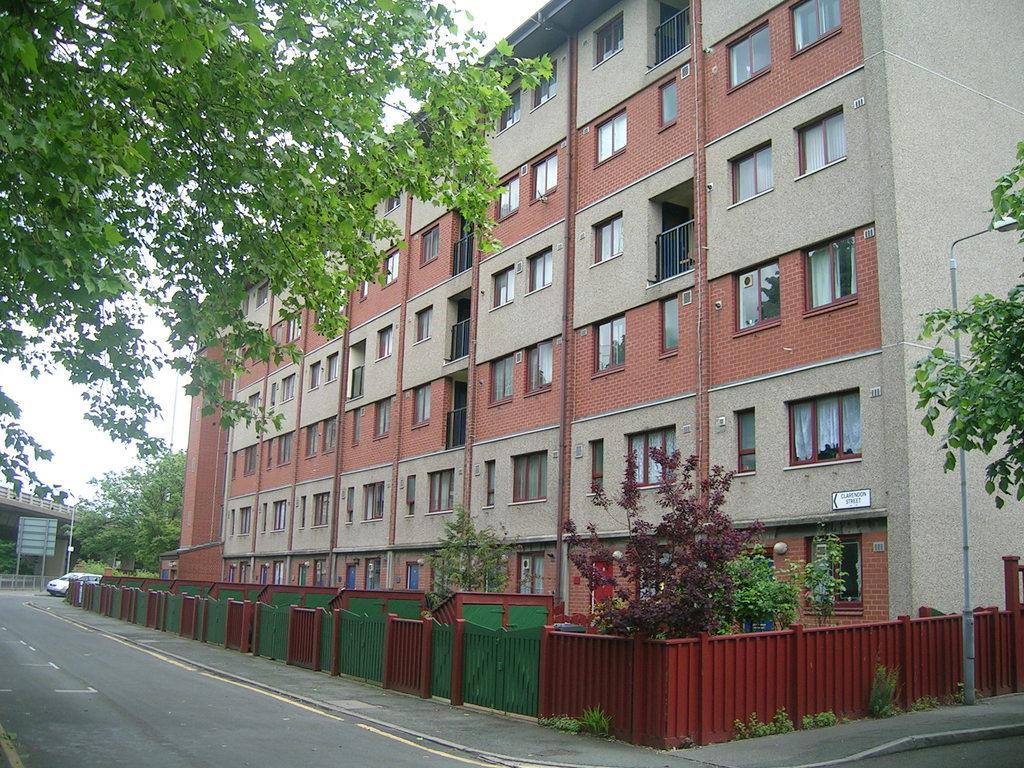Describe this image in one or two sentences. In this picture we can see a building on the right side, we can also see glass windows of the building, at the bottom there are some gates and fencing, we can see a pole and light here, on the left side there is a car, we can see some trees here, there is the sky at the top of the picture. 